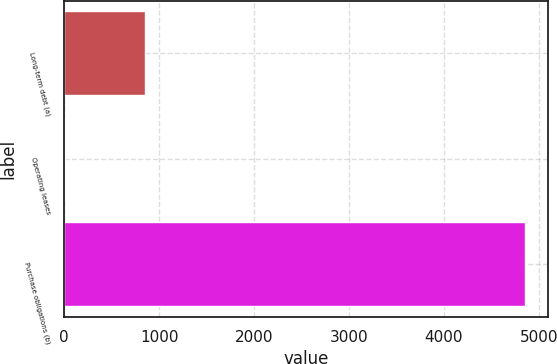Convert chart. <chart><loc_0><loc_0><loc_500><loc_500><bar_chart><fcel>Long-term debt (a)<fcel>Operating leases<fcel>Purchase obligations (b)<nl><fcel>851<fcel>8<fcel>4857<nl></chart> 